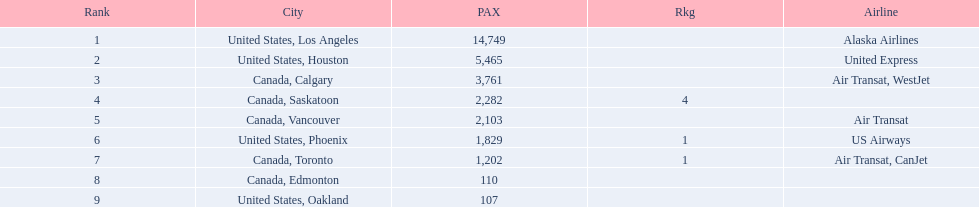What cities do the planes fly to? United States, Los Angeles, United States, Houston, Canada, Calgary, Canada, Saskatoon, Canada, Vancouver, United States, Phoenix, Canada, Toronto, Canada, Edmonton, United States, Oakland. How many people are flying to phoenix, arizona? 1,829. 